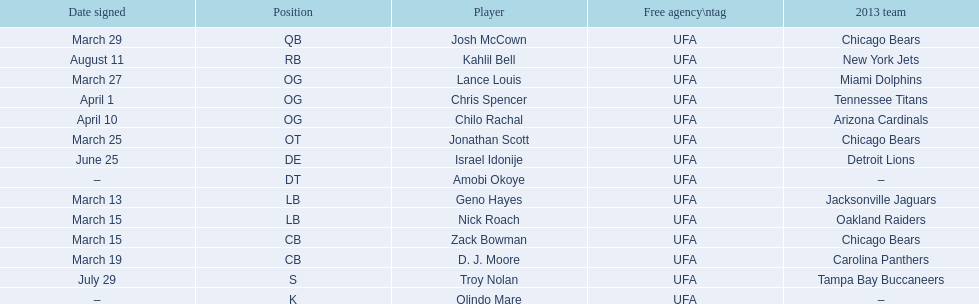Who are all the players on the 2013 chicago bears season team? Josh McCown, Kahlil Bell, Lance Louis, Chris Spencer, Chilo Rachal, Jonathan Scott, Israel Idonije, Amobi Okoye, Geno Hayes, Nick Roach, Zack Bowman, D. J. Moore, Troy Nolan, Olindo Mare. What day was nick roach signed? March 15. What other day matches this? March 15. Who was signed on the day? Zack Bowman. 